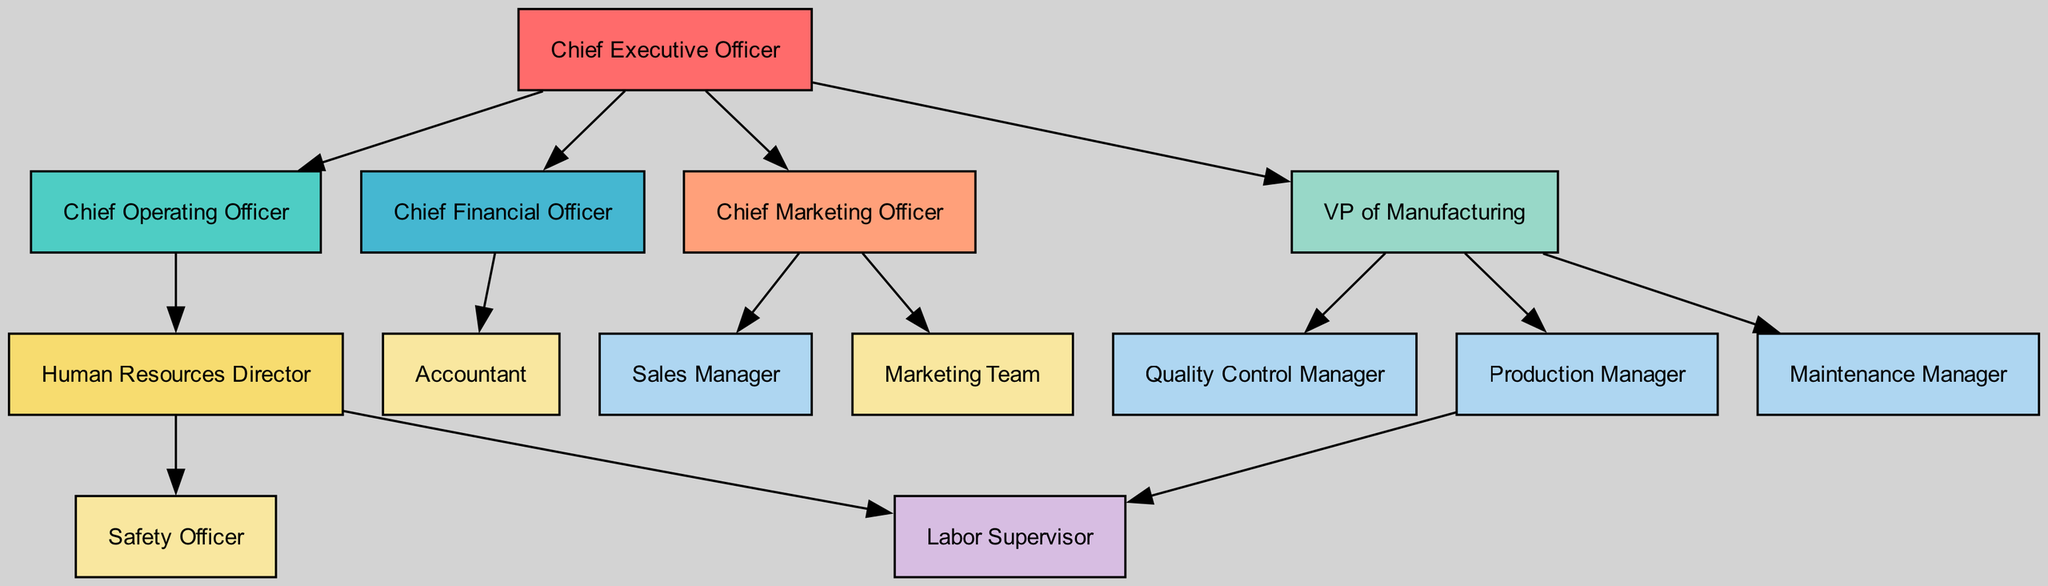What is the highest position in the hierarchy? The highest position in the hierarchy is represented by the node labeled "Chief Executive Officer," which connects to all other senior roles in the diagram.
Answer: Chief Executive Officer How many managerial positions are there? From the diagram, we have three managerial roles specifically identified: Production Manager, Maintenance Manager, and Quality Control Manager, leading to a total of three managerial positions.
Answer: 3 Who directly supervises the Labor Supervisor? The Labor Supervisor is directly supervised by both the Production Manager and the HR Director, as indicated by the arrows leading to this position.
Answer: Production Manager, HR Director What position is responsible for financial management? The position responsible for financial management is represented by the node labeled "Chief Financial Officer," which oversees the Accountant role in the organization.
Answer: Chief Financial Officer Which teams report to the Chief Marketing Officer? According to the diagram, the Chief Marketing Officer oversees both the Sales Manager and the Marketing Team, connecting them directly to the CMO role.
Answer: Sales Manager, Marketing Team How many edges connect the Chief Operating Officer to other positions? The Chief Operating Officer, according to the diagram, connects to two positions: the HR Director and the COO’s responsibilities, thus indicating a total of two outgoing edges.
Answer: 2 Which role is involved in ensuring workplace safety? The role responsible for ensuring workplace safety is labeled "Safety Officer," which has a direct connection to the HR Director, indicating a supportive relationship in this context.
Answer: Safety Officer What is the main role of the VP of Manufacturing? The Vice President of Manufacturing oversees production-related activities, being responsible for the Production Manager, Maintenance Manager, and Quality Control Manager roles as indicated by the connections.
Answer: VP of Manufacturing What team is directly connected to the Chief Marketing Officer? The Marketing Team has a direct connection to the Chief Marketing Officer, which is shown by the arrow linking them together in the organizational structure.
Answer: Marketing Team 